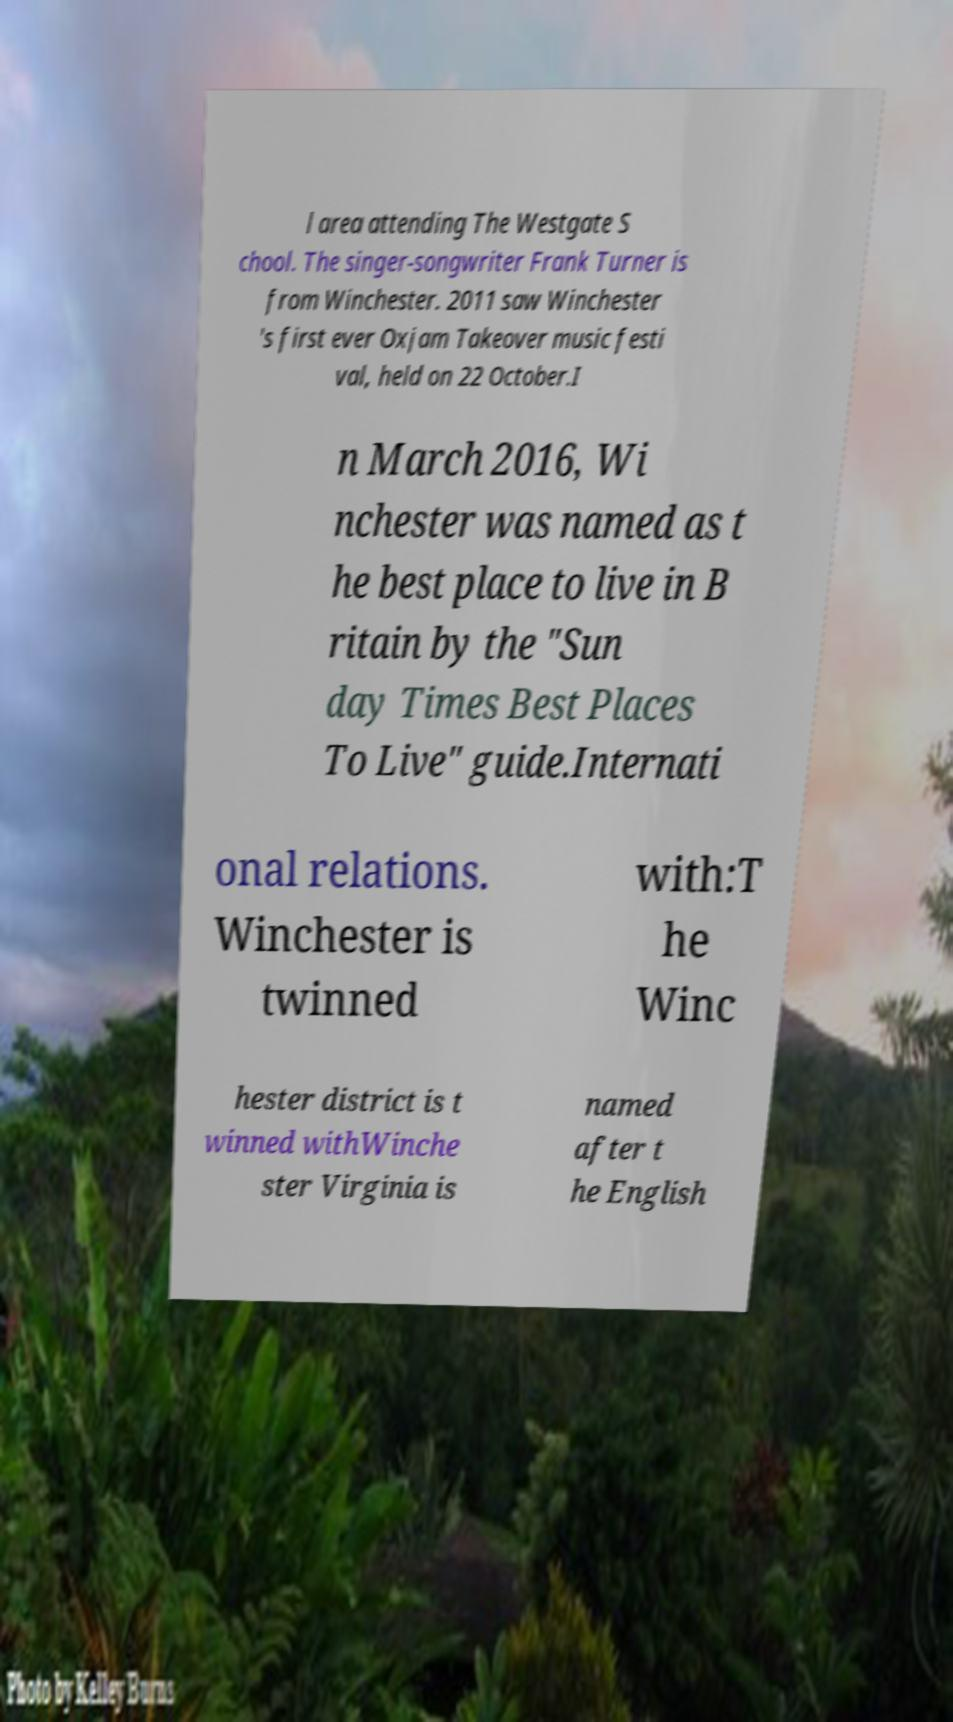There's text embedded in this image that I need extracted. Can you transcribe it verbatim? l area attending The Westgate S chool. The singer-songwriter Frank Turner is from Winchester. 2011 saw Winchester 's first ever Oxjam Takeover music festi val, held on 22 October.I n March 2016, Wi nchester was named as t he best place to live in B ritain by the "Sun day Times Best Places To Live" guide.Internati onal relations. Winchester is twinned with:T he Winc hester district is t winned withWinche ster Virginia is named after t he English 